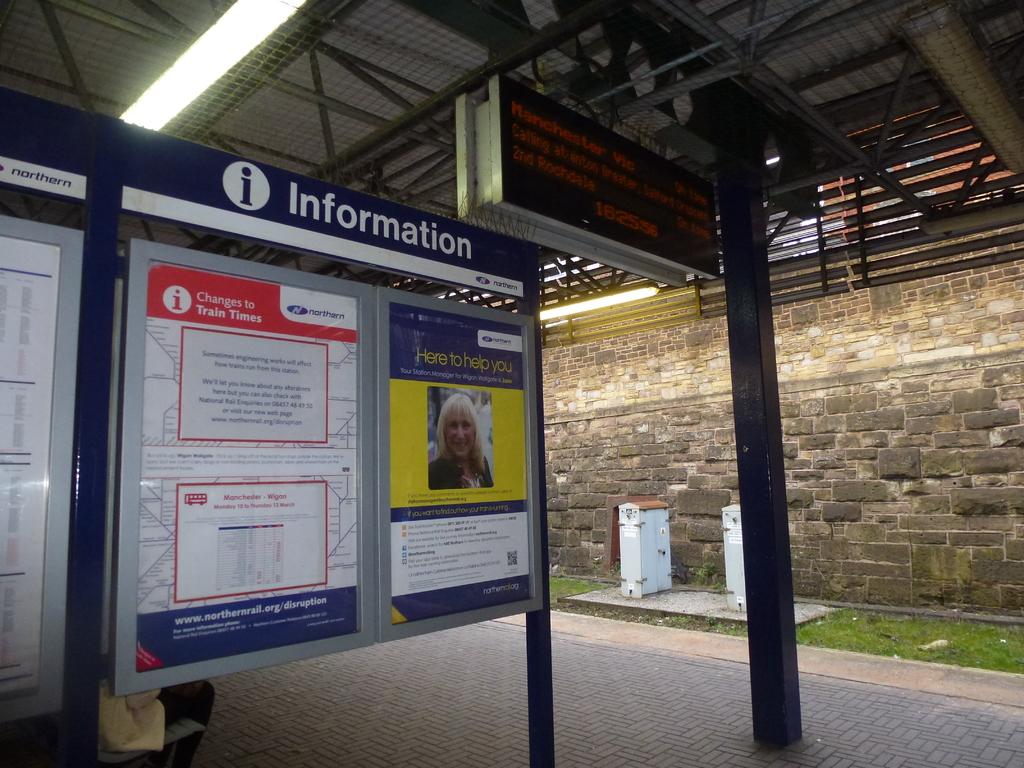What kind of board is this?
Keep it short and to the point. Information. 